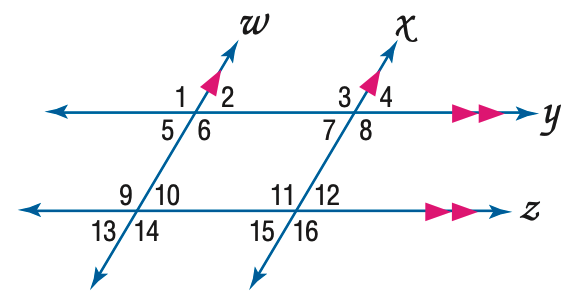Answer the mathemtical geometry problem and directly provide the correct option letter.
Question: In the figure, m \angle 12 = 64. Find the measure of \angle 3.
Choices: A: 104 B: 106 C: 114 D: 116 D 